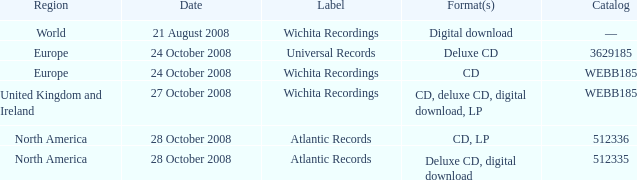What are the different formats connected to catalog number 512336 under the atlantic records label? CD, LP. 